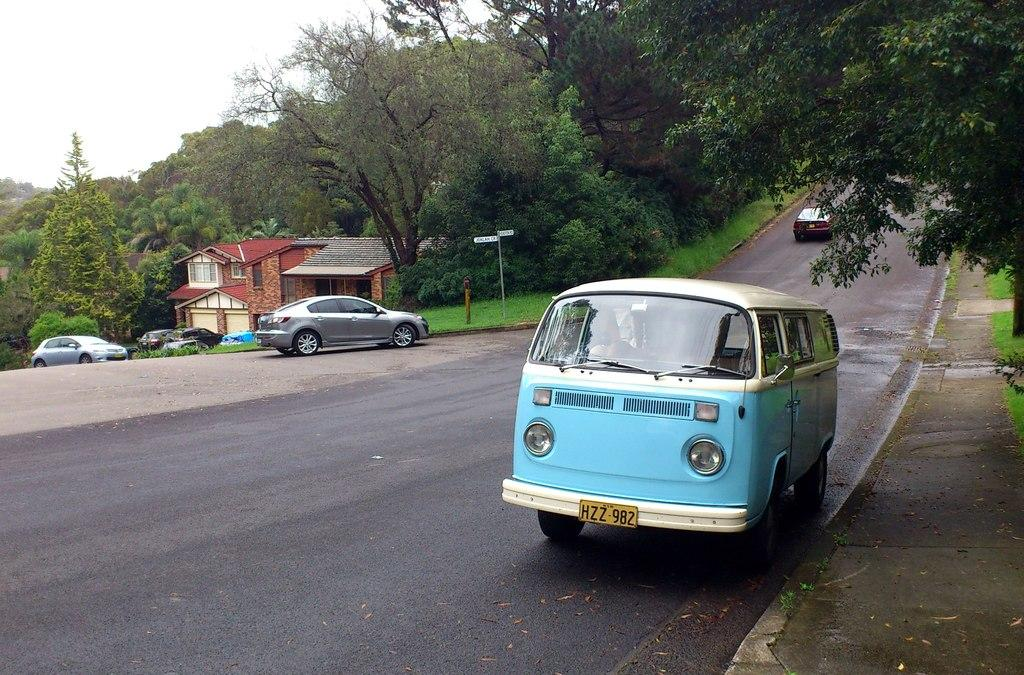What can be seen on the road in the image? There is a group of cars parked on the road. What is visible in the background of the image? There is a group of trees, a signboard, a building, and the sky visible in the background. How many cows are grazing on the road in the image? There are no cows present in the image; it features a group of cars parked on the road. What type of oil can be seen dripping from the signboard in the image? There is no oil present in the image, and the signboard does not appear to be dripping anything. 